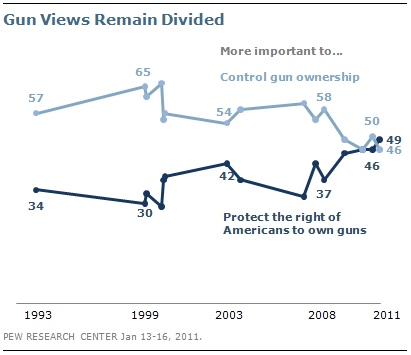Specify some key components in this picture. In 1993, the sum of two values is 91. The light blue line in the graph indicates a significant decrease in support for controlling gun ownership. 